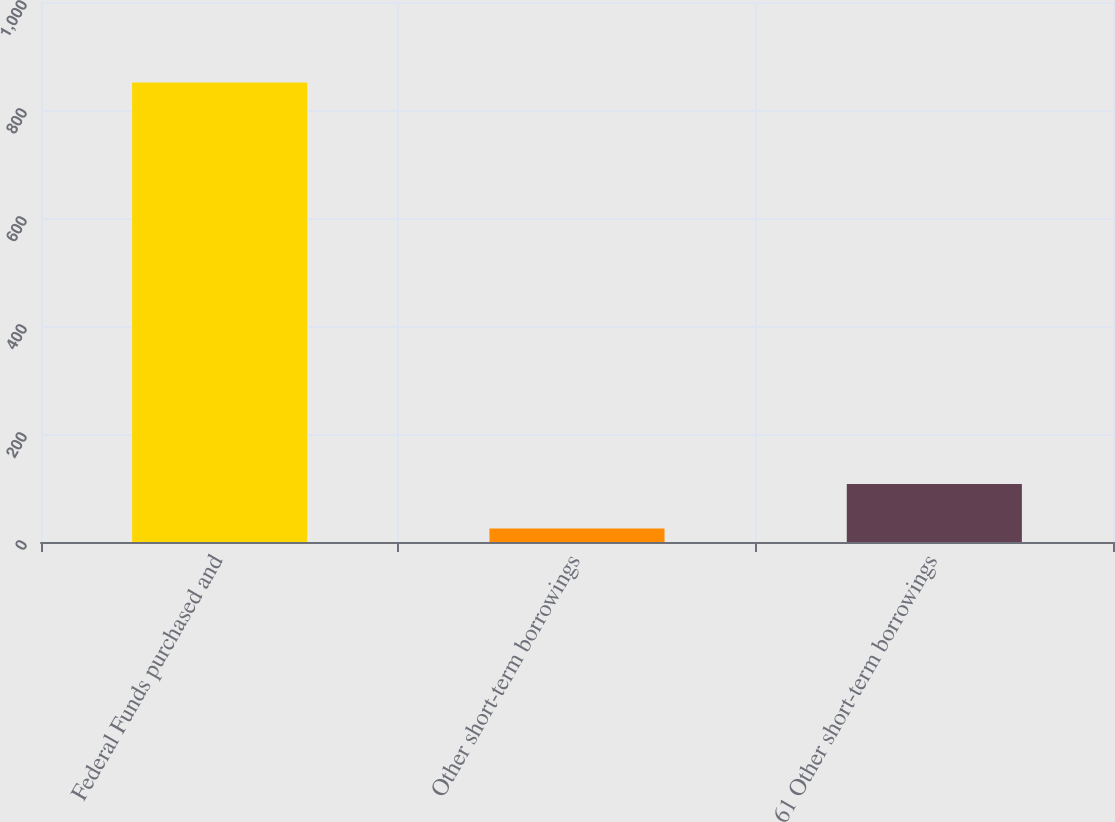Convert chart. <chart><loc_0><loc_0><loc_500><loc_500><bar_chart><fcel>Federal Funds purchased and<fcel>Other short-term borrowings<fcel>61 Other short-term borrowings<nl><fcel>851<fcel>25<fcel>107.6<nl></chart> 